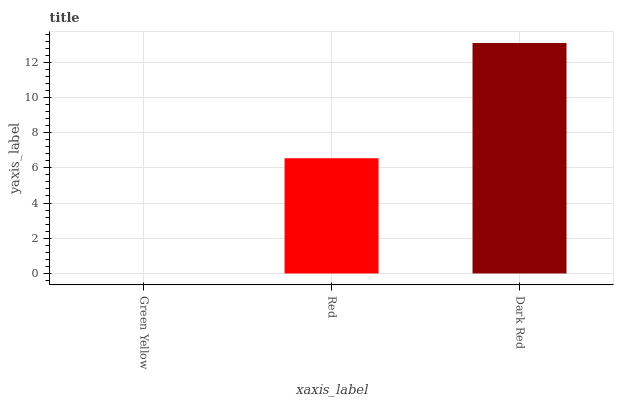Is Green Yellow the minimum?
Answer yes or no. Yes. Is Dark Red the maximum?
Answer yes or no. Yes. Is Red the minimum?
Answer yes or no. No. Is Red the maximum?
Answer yes or no. No. Is Red greater than Green Yellow?
Answer yes or no. Yes. Is Green Yellow less than Red?
Answer yes or no. Yes. Is Green Yellow greater than Red?
Answer yes or no. No. Is Red less than Green Yellow?
Answer yes or no. No. Is Red the high median?
Answer yes or no. Yes. Is Red the low median?
Answer yes or no. Yes. Is Dark Red the high median?
Answer yes or no. No. Is Dark Red the low median?
Answer yes or no. No. 